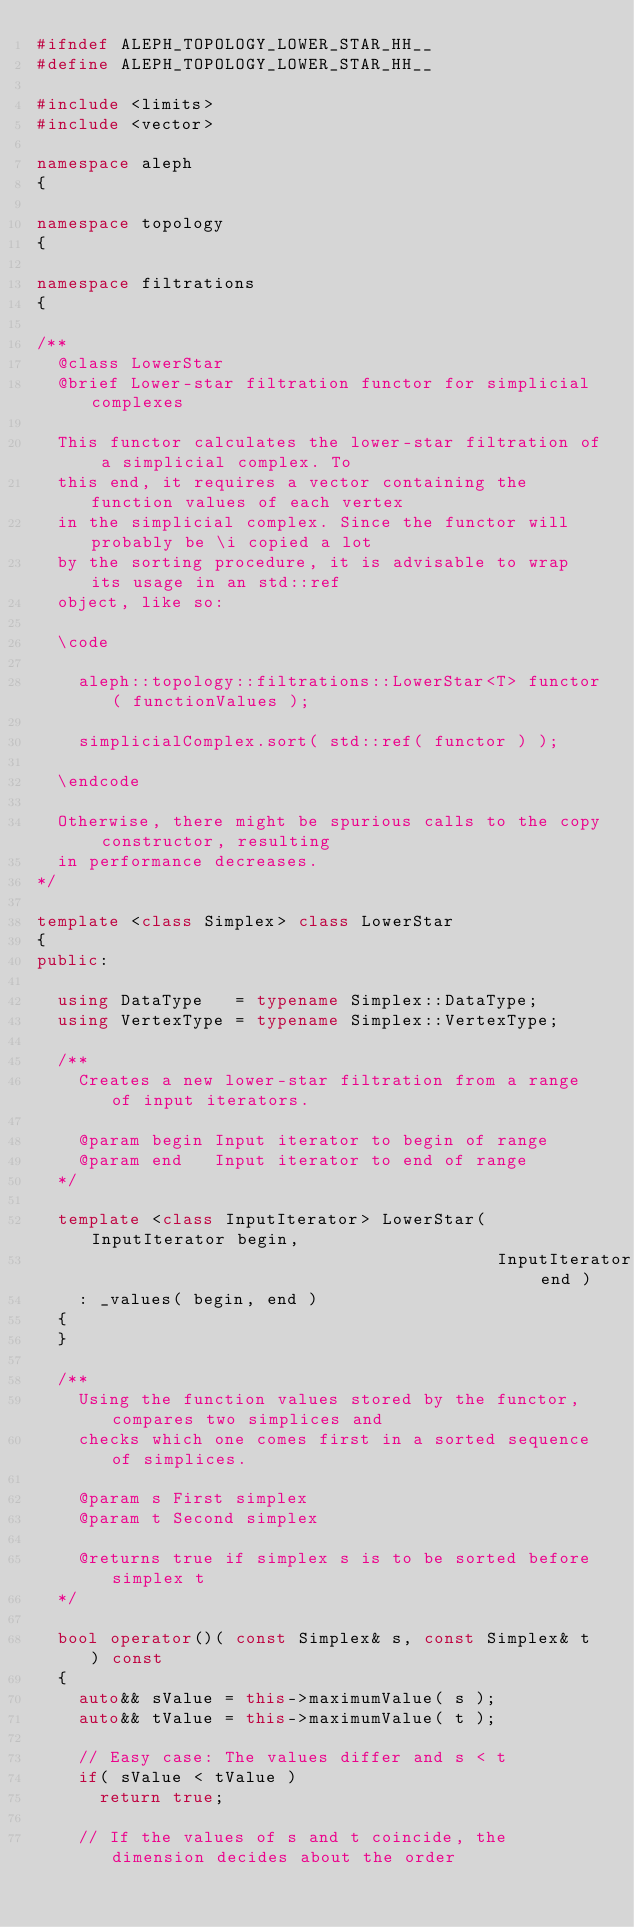Convert code to text. <code><loc_0><loc_0><loc_500><loc_500><_C++_>#ifndef ALEPH_TOPOLOGY_LOWER_STAR_HH__
#define ALEPH_TOPOLOGY_LOWER_STAR_HH__

#include <limits>
#include <vector>

namespace aleph
{

namespace topology
{

namespace filtrations
{

/**
  @class LowerStar
  @brief Lower-star filtration functor for simplicial complexes

  This functor calculates the lower-star filtration of a simplicial complex. To
  this end, it requires a vector containing the function values of each vertex
  in the simplicial complex. Since the functor will probably be \i copied a lot
  by the sorting procedure, it is advisable to wrap its usage in an std::ref
  object, like so:

  \code

    aleph::topology::filtrations::LowerStar<T> functor( functionValues );

    simplicialComplex.sort( std::ref( functor ) );

  \endcode

  Otherwise, there might be spurious calls to the copy constructor, resulting
  in performance decreases.
*/

template <class Simplex> class LowerStar
{
public:

  using DataType   = typename Simplex::DataType;
  using VertexType = typename Simplex::VertexType;

  /**
    Creates a new lower-star filtration from a range of input iterators.

    @param begin Input iterator to begin of range
    @param end   Input iterator to end of range
  */

  template <class InputIterator> LowerStar( InputIterator begin,
                                            InputIterator end )
    : _values( begin, end )
  {
  }

  /**
    Using the function values stored by the functor, compares two simplices and
    checks which one comes first in a sorted sequence of simplices.

    @param s First simplex
    @param t Second simplex

    @returns true if simplex s is to be sorted before simplex t
  */

  bool operator()( const Simplex& s, const Simplex& t ) const
  {
    auto&& sValue = this->maximumValue( s );
    auto&& tValue = this->maximumValue( t );

    // Easy case: The values differ and s < t
    if( sValue < tValue )
      return true;

    // If the values of s and t coincide, the dimension decides about the order</code> 